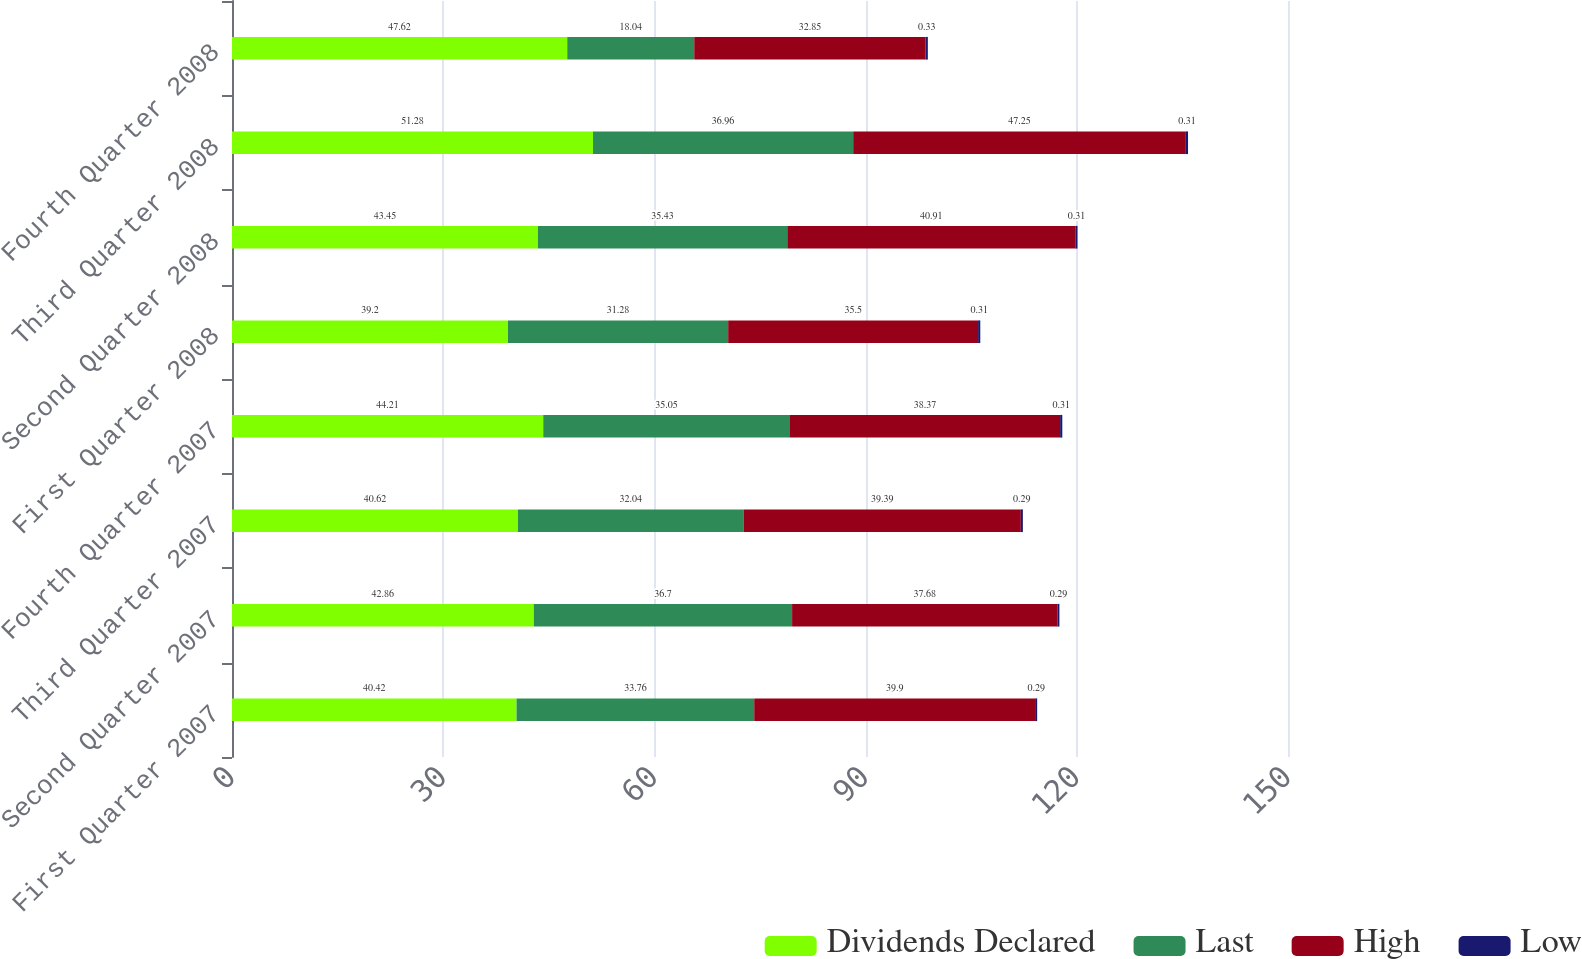<chart> <loc_0><loc_0><loc_500><loc_500><stacked_bar_chart><ecel><fcel>First Quarter 2007<fcel>Second Quarter 2007<fcel>Third Quarter 2007<fcel>Fourth Quarter 2007<fcel>First Quarter 2008<fcel>Second Quarter 2008<fcel>Third Quarter 2008<fcel>Fourth Quarter 2008<nl><fcel>Dividends Declared<fcel>40.42<fcel>42.86<fcel>40.62<fcel>44.21<fcel>39.2<fcel>43.45<fcel>51.28<fcel>47.62<nl><fcel>Last<fcel>33.76<fcel>36.7<fcel>32.04<fcel>35.05<fcel>31.28<fcel>35.43<fcel>36.96<fcel>18.04<nl><fcel>High<fcel>39.9<fcel>37.68<fcel>39.39<fcel>38.37<fcel>35.5<fcel>40.91<fcel>47.25<fcel>32.85<nl><fcel>Low<fcel>0.29<fcel>0.29<fcel>0.29<fcel>0.31<fcel>0.31<fcel>0.31<fcel>0.31<fcel>0.33<nl></chart> 